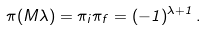Convert formula to latex. <formula><loc_0><loc_0><loc_500><loc_500>\pi ( M \lambda ) = \pi _ { i } \pi _ { f } = ( - 1 ) ^ { \lambda + 1 } \, .</formula> 